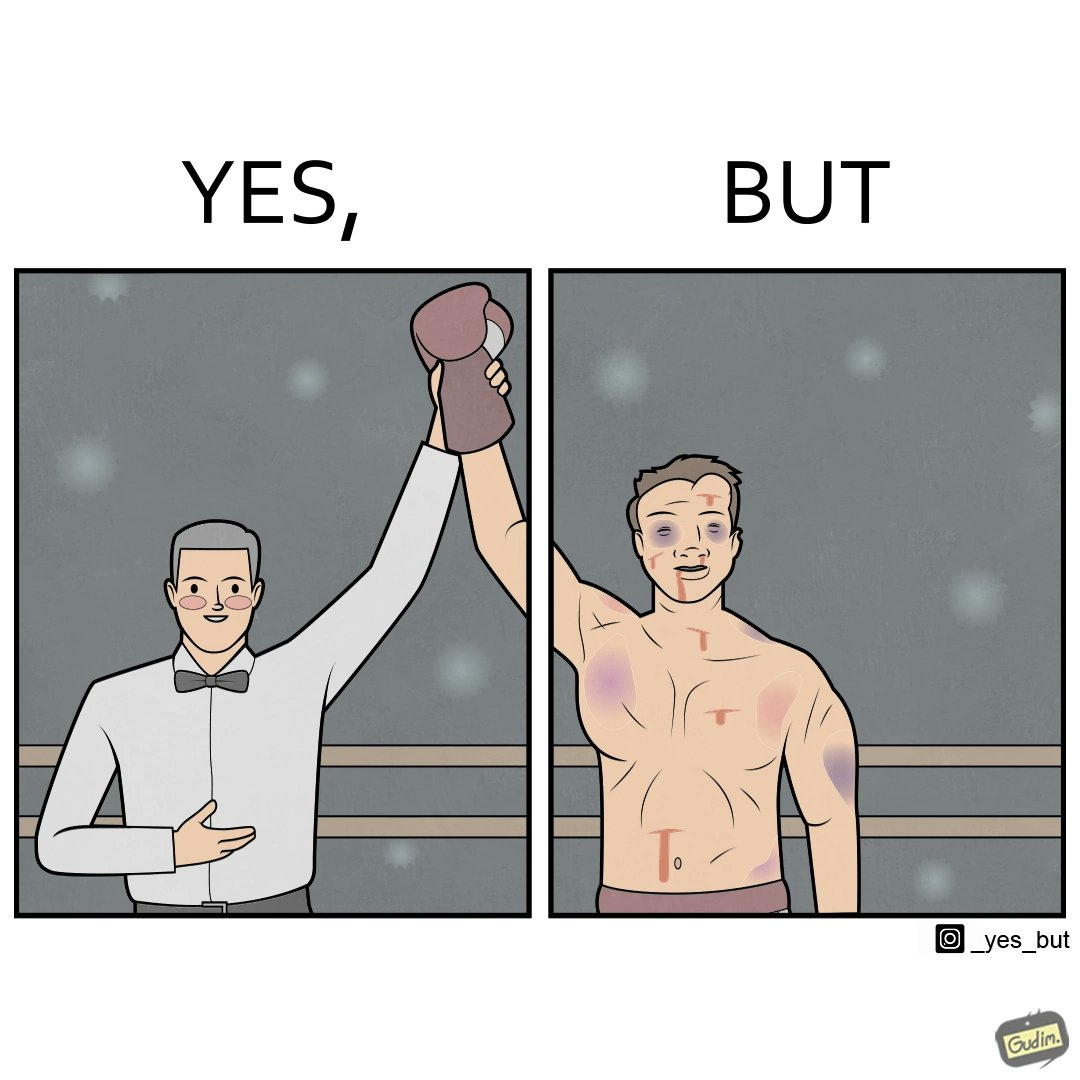Describe what you see in this image. The image is ironic because even though a boxer has won the match and it is supposed to be a moment of celebration, the boxer got bruised in several places during the match. This is an illustration of what hurdles a person has to go through in order to succeed. 